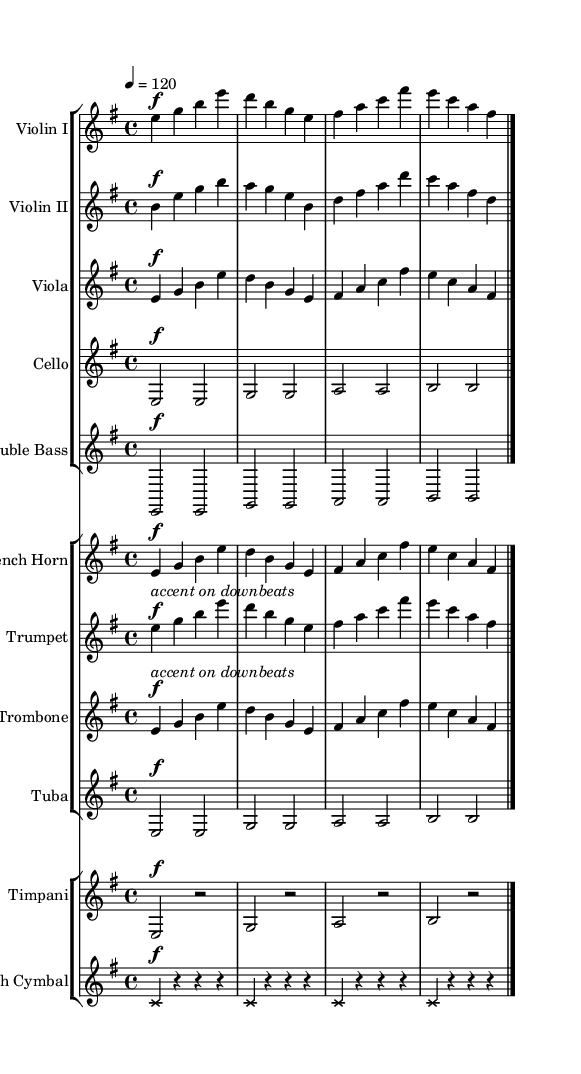What is the key signature of this music? The key signature is indicated at the beginning of the score and shows one sharp (F#), meaning it is E minor.
Answer: E minor What is the time signature of this piece? The time signature is found at the beginning of the score, showing the number of beats in a measure. In this case, it is 4/4, meaning there are four beats per measure.
Answer: 4/4 What is the tempo marking for this piece? The tempo is indicated at the beginning of the piece with "4 = 120," meaning there are 120 beats per minute.
Answer: 120 How many different instrument groups are there in this symphony? By examining the score layout, we can see that there are three groups: strings, brass, and percussion.
Answer: Three What dynamic marking is used for the Violin I part? The dynamic marking is present at the start of the Violin I part, indicated by "f," which stands for forte, meaning loud.
Answer: forte How many measures does the Violin II part contain? The Violin II part has a series of notes which can be counted along with the bar lines; in this case, it comprises four measures.
Answer: Four Which instrument plays the crash cymbal part? The crash cymbals are listed separately in the score, showing they have their own staff and part. This part specifically indicates the crash cymbals.
Answer: Crash Cymbal 